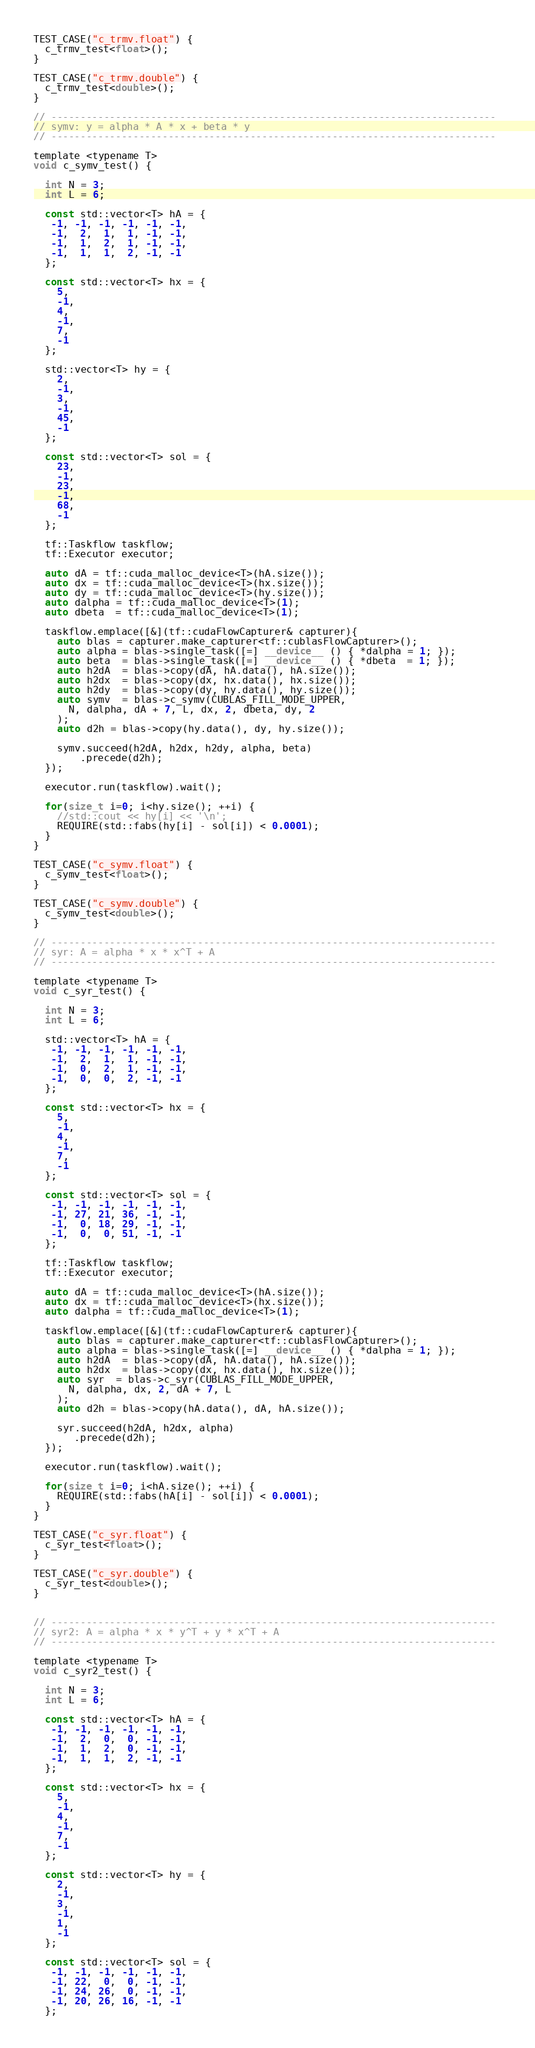Convert code to text. <code><loc_0><loc_0><loc_500><loc_500><_Cuda_>TEST_CASE("c_trmv.float") {
  c_trmv_test<float>();
}

TEST_CASE("c_trmv.double") {
  c_trmv_test<double>();
}

// ----------------------------------------------------------------------------
// symv: y = alpha * A * x + beta * y
// ----------------------------------------------------------------------------

template <typename T>
void c_symv_test() {

  int N = 3;
  int L = 6;

  const std::vector<T> hA = {
   -1, -1, -1, -1, -1, -1,
   -1,  2,  1,  1, -1, -1,
   -1,  1,  2,  1, -1, -1,
   -1,  1,  1,  2, -1, -1
  };

  const std::vector<T> hx = {
    5,
    -1,
    4,
    -1,
    7,
    -1
  };

  std::vector<T> hy = {
    2, 
    -1,
    3,
    -1,
    45,
    -1
  };

  const std::vector<T> sol = {
    23,
    -1,
    23,
    -1,
    68,
    -1
  };

  tf::Taskflow taskflow;
  tf::Executor executor;

  auto dA = tf::cuda_malloc_device<T>(hA.size());
  auto dx = tf::cuda_malloc_device<T>(hx.size());
  auto dy = tf::cuda_malloc_device<T>(hy.size());
  auto dalpha = tf::cuda_malloc_device<T>(1);
  auto dbeta  = tf::cuda_malloc_device<T>(1);

  taskflow.emplace([&](tf::cudaFlowCapturer& capturer){
    auto blas = capturer.make_capturer<tf::cublasFlowCapturer>();
    auto alpha = blas->single_task([=] __device__ () { *dalpha = 1; });
    auto beta  = blas->single_task([=] __device__ () { *dbeta  = 1; });
    auto h2dA  = blas->copy(dA, hA.data(), hA.size());
    auto h2dx  = blas->copy(dx, hx.data(), hx.size());
    auto h2dy  = blas->copy(dy, hy.data(), hy.size());
    auto symv  = blas->c_symv(CUBLAS_FILL_MODE_UPPER, 
      N, dalpha, dA + 7, L, dx, 2, dbeta, dy, 2
    );
    auto d2h = blas->copy(hy.data(), dy, hy.size());

    symv.succeed(h2dA, h2dx, h2dy, alpha, beta)
        .precede(d2h);
  });

  executor.run(taskflow).wait();
  
  for(size_t i=0; i<hy.size(); ++i) {
    //std::cout << hy[i] << '\n';
    REQUIRE(std::fabs(hy[i] - sol[i]) < 0.0001);
  }
}

TEST_CASE("c_symv.float") {
  c_symv_test<float>();
}

TEST_CASE("c_symv.double") {
  c_symv_test<double>();
}

// ---------------------------------------------------------------------------- 
// syr: A = alpha * x * x^T + A
// ---------------------------------------------------------------------------- 

template <typename T>
void c_syr_test() {

  int N = 3;
  int L = 6;

  std::vector<T> hA = {
   -1, -1, -1, -1, -1, -1,
   -1,  2,  1,  1, -1, -1,
   -1,  0,  2,  1, -1, -1,
   -1,  0,  0,  2, -1, -1
  };

  const std::vector<T> hx = {
    5,
    -1,
    4,
    -1,
    7,
    -1
  };

  const std::vector<T> sol = {
   -1, -1, -1, -1, -1, -1,
   -1, 27, 21, 36, -1, -1,
   -1,  0, 18, 29, -1, -1,
   -1,  0,  0, 51, -1, -1
  };

  tf::Taskflow taskflow;
  tf::Executor executor;

  auto dA = tf::cuda_malloc_device<T>(hA.size());
  auto dx = tf::cuda_malloc_device<T>(hx.size());
  auto dalpha = tf::cuda_malloc_device<T>(1);

  taskflow.emplace([&](tf::cudaFlowCapturer& capturer){
    auto blas = capturer.make_capturer<tf::cublasFlowCapturer>();
    auto alpha = blas->single_task([=] __device__ () { *dalpha = 1; });
    auto h2dA  = blas->copy(dA, hA.data(), hA.size());
    auto h2dx  = blas->copy(dx, hx.data(), hx.size());
    auto syr  = blas->c_syr(CUBLAS_FILL_MODE_UPPER, 
      N, dalpha, dx, 2, dA + 7, L
    );
    auto d2h = blas->copy(hA.data(), dA, hA.size());

    syr.succeed(h2dA, h2dx, alpha) 
       .precede(d2h);
  });

  executor.run(taskflow).wait();
  
  for(size_t i=0; i<hA.size(); ++i) {
    REQUIRE(std::fabs(hA[i] - sol[i]) < 0.0001);
  }
}

TEST_CASE("c_syr.float") {
  c_syr_test<float>();
}

TEST_CASE("c_syr.double") {
  c_syr_test<double>();
}


// ----------------------------------------------------------------------------
// syr2: A = alpha * x * y^T + y * x^T + A
// ----------------------------------------------------------------------------

template <typename T>
void c_syr2_test() {

  int N = 3;
  int L = 6;

  const std::vector<T> hA = {
   -1, -1, -1, -1, -1, -1,
   -1,  2,  0,  0, -1, -1,
   -1,  1,  2,  0, -1, -1,
   -1,  1,  1,  2, -1, -1
  };

  const std::vector<T> hx = {
    5,
    -1,
    4,
    -1,
    7,
    -1
  };

  const std::vector<T> hy = {
    2, 
    -1,
    3,
    -1,
    1,
    -1
  };

  const std::vector<T> sol = {
   -1, -1, -1, -1, -1, -1,
   -1, 22,  0,  0, -1, -1,
   -1, 24, 26,  0, -1, -1,
   -1, 20, 26, 16, -1, -1
  };
</code> 